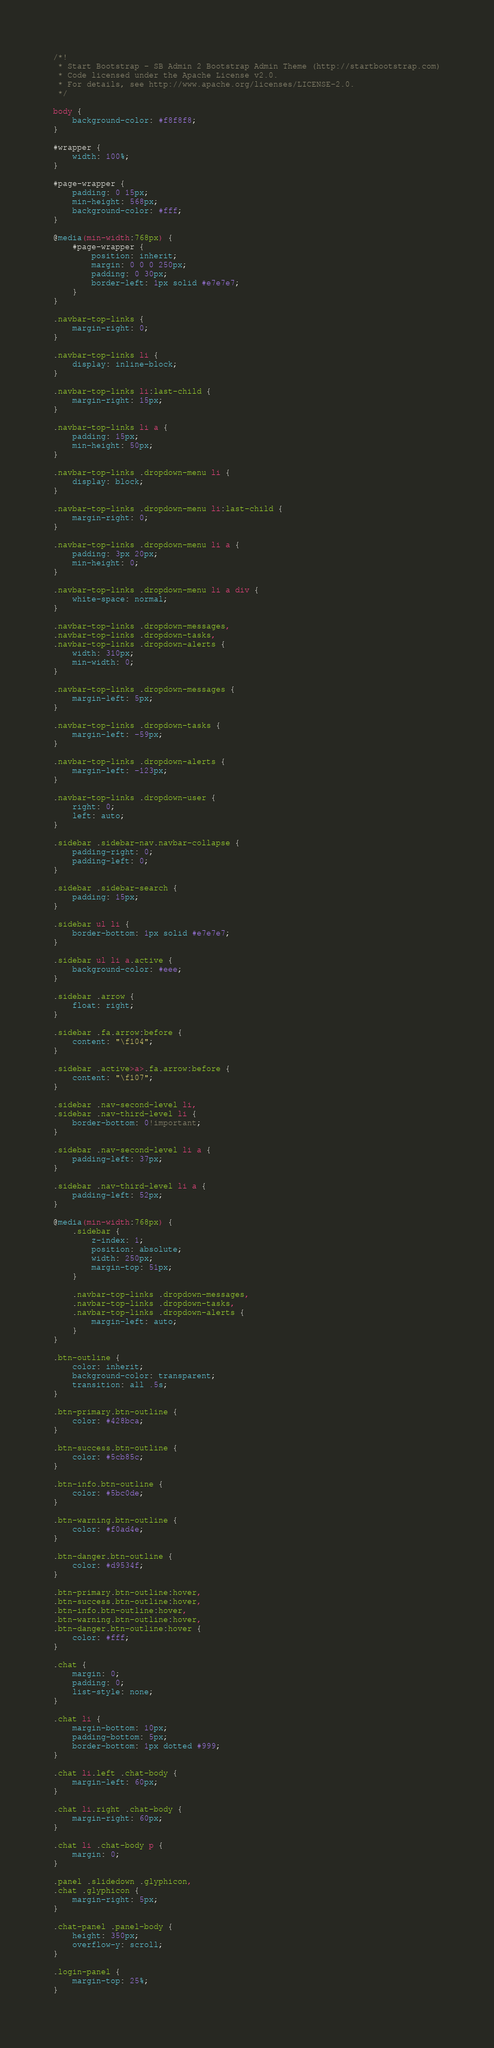<code> <loc_0><loc_0><loc_500><loc_500><_CSS_>/*!
 * Start Bootstrap - SB Admin 2 Bootstrap Admin Theme (http://startbootstrap.com)
 * Code licensed under the Apache License v2.0.
 * For details, see http://www.apache.org/licenses/LICENSE-2.0.
 */

body {
    background-color: #f8f8f8;
}

#wrapper {
    width: 100%;
}

#page-wrapper {
    padding: 0 15px;
    min-height: 568px;
    background-color: #fff;
}

@media(min-width:768px) {
    #page-wrapper {
        position: inherit;
        margin: 0 0 0 250px;
        padding: 0 30px;
        border-left: 1px solid #e7e7e7;
    }
}

.navbar-top-links {
    margin-right: 0;
}

.navbar-top-links li {
    display: inline-block;
}

.navbar-top-links li:last-child {
    margin-right: 15px;
}

.navbar-top-links li a {
    padding: 15px;
    min-height: 50px;
}

.navbar-top-links .dropdown-menu li {
    display: block;
}

.navbar-top-links .dropdown-menu li:last-child {
    margin-right: 0;
}

.navbar-top-links .dropdown-menu li a {
    padding: 3px 20px;
    min-height: 0;
}

.navbar-top-links .dropdown-menu li a div {
    white-space: normal;
}

.navbar-top-links .dropdown-messages,
.navbar-top-links .dropdown-tasks,
.navbar-top-links .dropdown-alerts {
    width: 310px;
    min-width: 0;
}

.navbar-top-links .dropdown-messages {
    margin-left: 5px;
}

.navbar-top-links .dropdown-tasks {
    margin-left: -59px;
}

.navbar-top-links .dropdown-alerts {
    margin-left: -123px;
}

.navbar-top-links .dropdown-user {
    right: 0;
    left: auto;
}

.sidebar .sidebar-nav.navbar-collapse {
    padding-right: 0;
    padding-left: 0;
}

.sidebar .sidebar-search {
    padding: 15px;
}

.sidebar ul li {
    border-bottom: 1px solid #e7e7e7;
}

.sidebar ul li a.active {
    background-color: #eee;
}

.sidebar .arrow {
    float: right;
}

.sidebar .fa.arrow:before {
    content: "\f104";
}

.sidebar .active>a>.fa.arrow:before {
    content: "\f107";
}

.sidebar .nav-second-level li,
.sidebar .nav-third-level li {
    border-bottom: 0!important;
}

.sidebar .nav-second-level li a {
    padding-left: 37px;
}

.sidebar .nav-third-level li a {
    padding-left: 52px;
}

@media(min-width:768px) {
    .sidebar {
        z-index: 1;
        position: absolute;
        width: 250px;
        margin-top: 51px;
    }

    .navbar-top-links .dropdown-messages,
    .navbar-top-links .dropdown-tasks,
    .navbar-top-links .dropdown-alerts {
        margin-left: auto;
    }
}

.btn-outline {
    color: inherit;
    background-color: transparent;
    transition: all .5s;
}

.btn-primary.btn-outline {
    color: #428bca;
}

.btn-success.btn-outline {
    color: #5cb85c;
}

.btn-info.btn-outline {
    color: #5bc0de;
}

.btn-warning.btn-outline {
    color: #f0ad4e;
}

.btn-danger.btn-outline {
    color: #d9534f;
}

.btn-primary.btn-outline:hover,
.btn-success.btn-outline:hover,
.btn-info.btn-outline:hover,
.btn-warning.btn-outline:hover,
.btn-danger.btn-outline:hover {
    color: #fff;
}

.chat {
    margin: 0;
    padding: 0;
    list-style: none;
}

.chat li {
    margin-bottom: 10px;
    padding-bottom: 5px;
    border-bottom: 1px dotted #999;
}

.chat li.left .chat-body {
    margin-left: 60px;
}

.chat li.right .chat-body {
    margin-right: 60px;
}

.chat li .chat-body p {
    margin: 0;
}

.panel .slidedown .glyphicon,
.chat .glyphicon {
    margin-right: 5px;
}

.chat-panel .panel-body {
    height: 350px;
    overflow-y: scroll;
}

.login-panel {
    margin-top: 25%;
}
</code> 